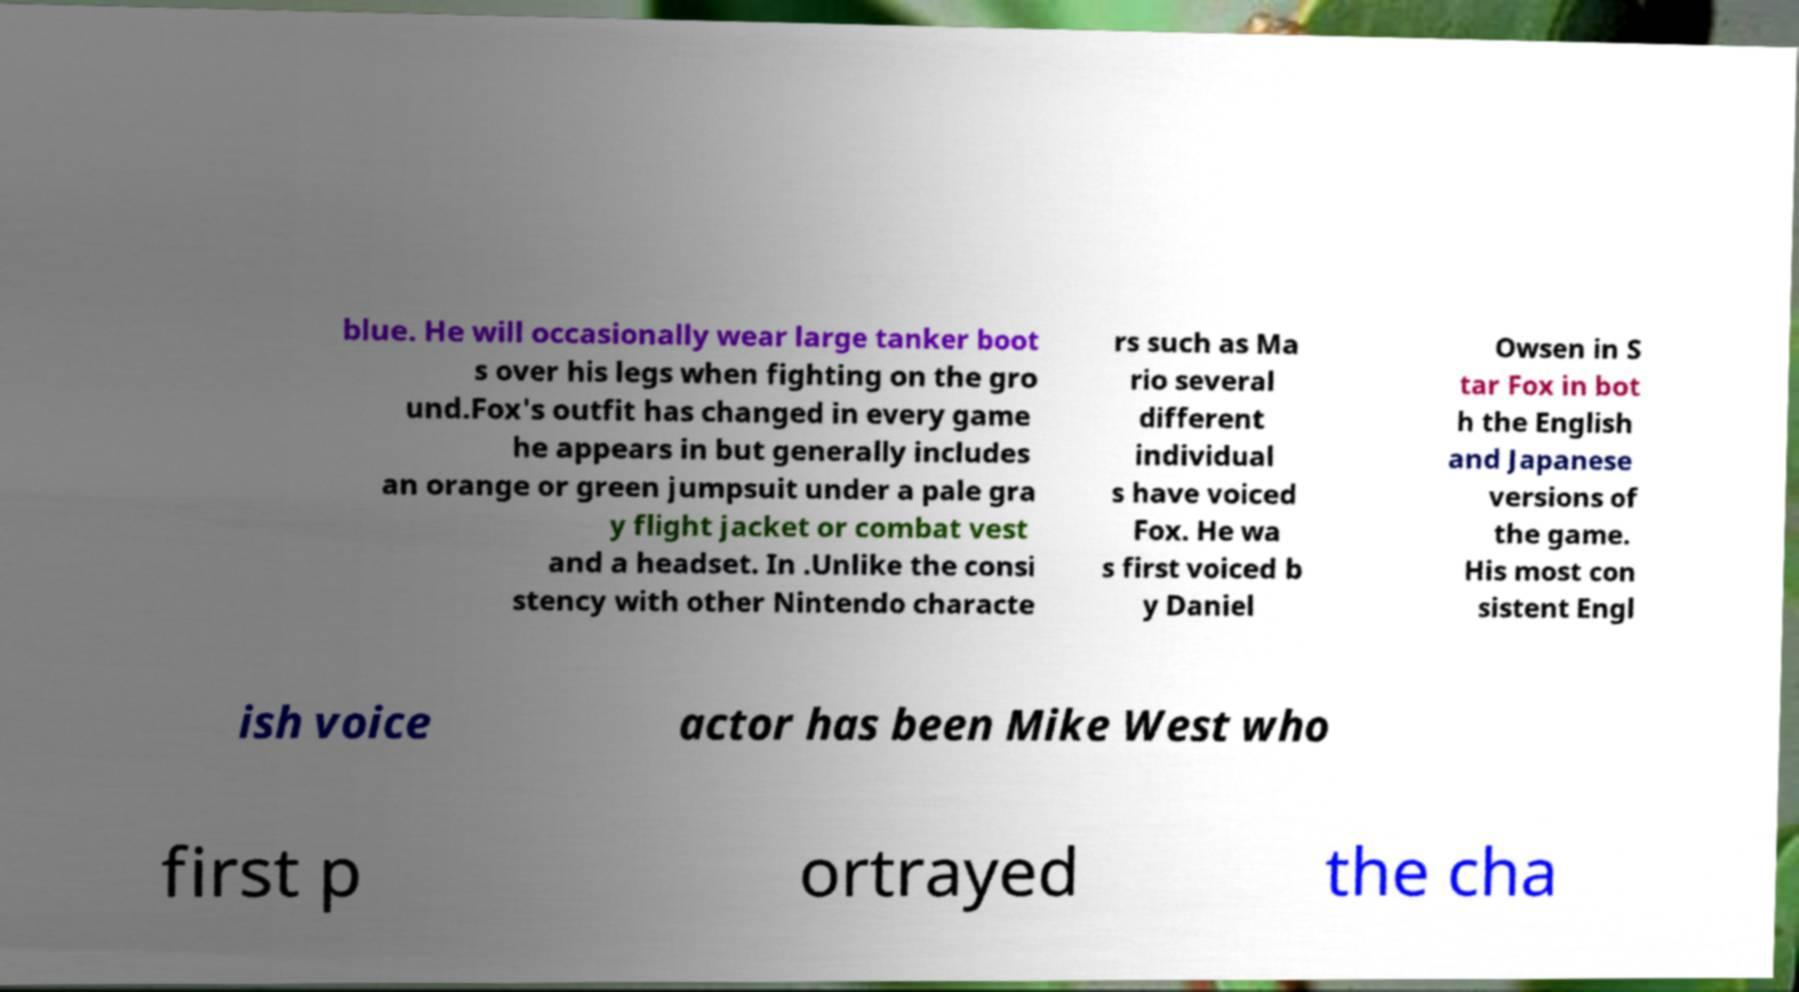What messages or text are displayed in this image? I need them in a readable, typed format. blue. He will occasionally wear large tanker boot s over his legs when fighting on the gro und.Fox's outfit has changed in every game he appears in but generally includes an orange or green jumpsuit under a pale gra y flight jacket or combat vest and a headset. In .Unlike the consi stency with other Nintendo characte rs such as Ma rio several different individual s have voiced Fox. He wa s first voiced b y Daniel Owsen in S tar Fox in bot h the English and Japanese versions of the game. His most con sistent Engl ish voice actor has been Mike West who first p ortrayed the cha 